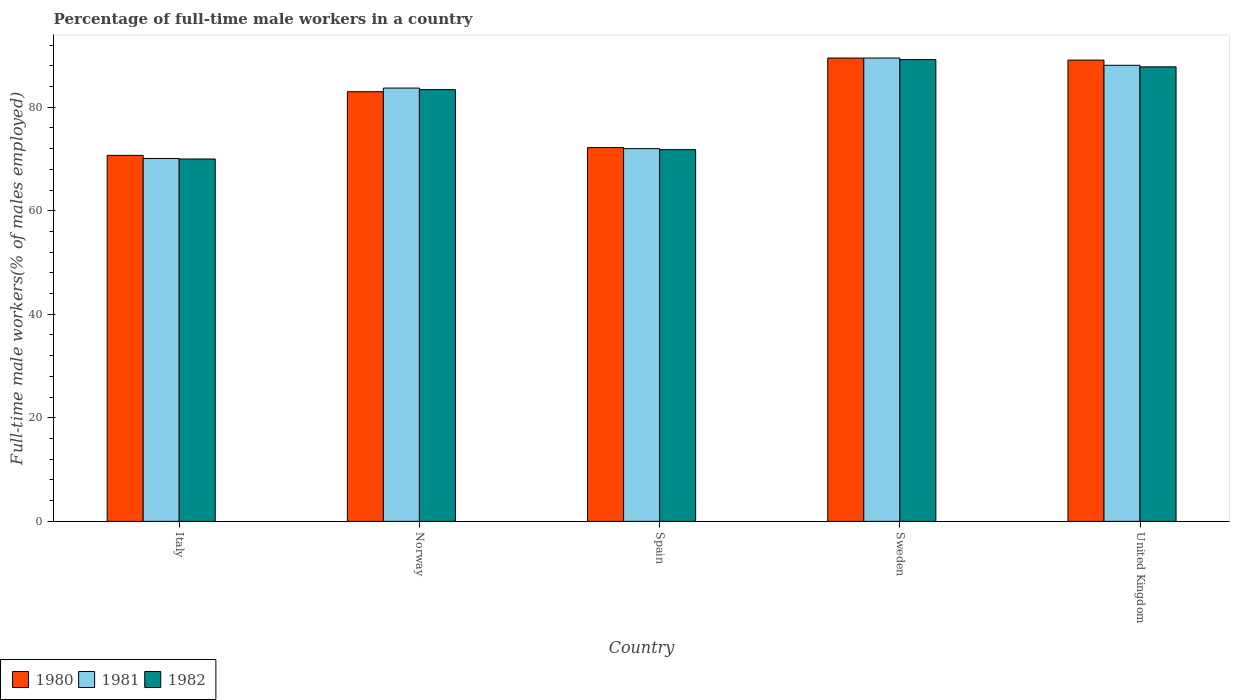How many different coloured bars are there?
Give a very brief answer. 3. How many groups of bars are there?
Provide a short and direct response. 5. Are the number of bars per tick equal to the number of legend labels?
Your answer should be compact. Yes. Are the number of bars on each tick of the X-axis equal?
Offer a terse response. Yes. How many bars are there on the 5th tick from the right?
Provide a succinct answer. 3. What is the label of the 1st group of bars from the left?
Give a very brief answer. Italy. In how many cases, is the number of bars for a given country not equal to the number of legend labels?
Your answer should be compact. 0. What is the percentage of full-time male workers in 1982 in United Kingdom?
Your response must be concise. 87.8. Across all countries, what is the maximum percentage of full-time male workers in 1982?
Offer a terse response. 89.2. Across all countries, what is the minimum percentage of full-time male workers in 1982?
Keep it short and to the point. 70. In which country was the percentage of full-time male workers in 1981 maximum?
Your response must be concise. Sweden. In which country was the percentage of full-time male workers in 1981 minimum?
Provide a succinct answer. Italy. What is the total percentage of full-time male workers in 1980 in the graph?
Offer a terse response. 404.5. What is the difference between the percentage of full-time male workers in 1981 in Spain and the percentage of full-time male workers in 1980 in Italy?
Your response must be concise. 1.3. What is the average percentage of full-time male workers in 1981 per country?
Provide a succinct answer. 80.68. What is the difference between the percentage of full-time male workers of/in 1982 and percentage of full-time male workers of/in 1981 in Sweden?
Keep it short and to the point. -0.3. In how many countries, is the percentage of full-time male workers in 1980 greater than 24 %?
Provide a succinct answer. 5. What is the ratio of the percentage of full-time male workers in 1982 in Norway to that in United Kingdom?
Make the answer very short. 0.95. What is the difference between the highest and the second highest percentage of full-time male workers in 1980?
Your answer should be very brief. -0.4. What is the difference between the highest and the lowest percentage of full-time male workers in 1982?
Offer a terse response. 19.2. Is the sum of the percentage of full-time male workers in 1980 in Italy and Norway greater than the maximum percentage of full-time male workers in 1982 across all countries?
Offer a very short reply. Yes. What does the 2nd bar from the left in Spain represents?
Provide a short and direct response. 1981. What does the 3rd bar from the right in Italy represents?
Offer a very short reply. 1980. How many bars are there?
Provide a short and direct response. 15. Are all the bars in the graph horizontal?
Provide a short and direct response. No. How many countries are there in the graph?
Make the answer very short. 5. Does the graph contain any zero values?
Give a very brief answer. No. Does the graph contain grids?
Your answer should be compact. No. How many legend labels are there?
Keep it short and to the point. 3. How are the legend labels stacked?
Keep it short and to the point. Horizontal. What is the title of the graph?
Offer a terse response. Percentage of full-time male workers in a country. What is the label or title of the Y-axis?
Your response must be concise. Full-time male workers(% of males employed). What is the Full-time male workers(% of males employed) of 1980 in Italy?
Your response must be concise. 70.7. What is the Full-time male workers(% of males employed) of 1981 in Italy?
Ensure brevity in your answer.  70.1. What is the Full-time male workers(% of males employed) of 1982 in Italy?
Keep it short and to the point. 70. What is the Full-time male workers(% of males employed) in 1980 in Norway?
Keep it short and to the point. 83. What is the Full-time male workers(% of males employed) of 1981 in Norway?
Provide a succinct answer. 83.7. What is the Full-time male workers(% of males employed) in 1982 in Norway?
Ensure brevity in your answer.  83.4. What is the Full-time male workers(% of males employed) of 1980 in Spain?
Make the answer very short. 72.2. What is the Full-time male workers(% of males employed) of 1981 in Spain?
Provide a short and direct response. 72. What is the Full-time male workers(% of males employed) in 1982 in Spain?
Provide a succinct answer. 71.8. What is the Full-time male workers(% of males employed) of 1980 in Sweden?
Offer a terse response. 89.5. What is the Full-time male workers(% of males employed) in 1981 in Sweden?
Offer a very short reply. 89.5. What is the Full-time male workers(% of males employed) in 1982 in Sweden?
Offer a terse response. 89.2. What is the Full-time male workers(% of males employed) of 1980 in United Kingdom?
Your answer should be compact. 89.1. What is the Full-time male workers(% of males employed) of 1981 in United Kingdom?
Offer a very short reply. 88.1. What is the Full-time male workers(% of males employed) in 1982 in United Kingdom?
Offer a very short reply. 87.8. Across all countries, what is the maximum Full-time male workers(% of males employed) of 1980?
Provide a short and direct response. 89.5. Across all countries, what is the maximum Full-time male workers(% of males employed) of 1981?
Keep it short and to the point. 89.5. Across all countries, what is the maximum Full-time male workers(% of males employed) in 1982?
Offer a terse response. 89.2. Across all countries, what is the minimum Full-time male workers(% of males employed) of 1980?
Your answer should be compact. 70.7. Across all countries, what is the minimum Full-time male workers(% of males employed) of 1981?
Provide a short and direct response. 70.1. Across all countries, what is the minimum Full-time male workers(% of males employed) in 1982?
Your answer should be compact. 70. What is the total Full-time male workers(% of males employed) of 1980 in the graph?
Your answer should be compact. 404.5. What is the total Full-time male workers(% of males employed) of 1981 in the graph?
Your answer should be compact. 403.4. What is the total Full-time male workers(% of males employed) in 1982 in the graph?
Provide a short and direct response. 402.2. What is the difference between the Full-time male workers(% of males employed) of 1980 in Italy and that in Norway?
Your answer should be compact. -12.3. What is the difference between the Full-time male workers(% of males employed) of 1981 in Italy and that in Norway?
Your answer should be compact. -13.6. What is the difference between the Full-time male workers(% of males employed) of 1980 in Italy and that in Spain?
Make the answer very short. -1.5. What is the difference between the Full-time male workers(% of males employed) in 1981 in Italy and that in Spain?
Provide a short and direct response. -1.9. What is the difference between the Full-time male workers(% of males employed) in 1980 in Italy and that in Sweden?
Your response must be concise. -18.8. What is the difference between the Full-time male workers(% of males employed) of 1981 in Italy and that in Sweden?
Provide a succinct answer. -19.4. What is the difference between the Full-time male workers(% of males employed) of 1982 in Italy and that in Sweden?
Offer a very short reply. -19.2. What is the difference between the Full-time male workers(% of males employed) of 1980 in Italy and that in United Kingdom?
Your response must be concise. -18.4. What is the difference between the Full-time male workers(% of males employed) in 1981 in Italy and that in United Kingdom?
Your answer should be very brief. -18. What is the difference between the Full-time male workers(% of males employed) of 1982 in Italy and that in United Kingdom?
Provide a succinct answer. -17.8. What is the difference between the Full-time male workers(% of males employed) in 1980 in Norway and that in Spain?
Make the answer very short. 10.8. What is the difference between the Full-time male workers(% of males employed) of 1982 in Norway and that in Spain?
Your response must be concise. 11.6. What is the difference between the Full-time male workers(% of males employed) in 1982 in Norway and that in Sweden?
Provide a short and direct response. -5.8. What is the difference between the Full-time male workers(% of males employed) in 1980 in Norway and that in United Kingdom?
Make the answer very short. -6.1. What is the difference between the Full-time male workers(% of males employed) in 1982 in Norway and that in United Kingdom?
Offer a terse response. -4.4. What is the difference between the Full-time male workers(% of males employed) in 1980 in Spain and that in Sweden?
Your answer should be compact. -17.3. What is the difference between the Full-time male workers(% of males employed) of 1981 in Spain and that in Sweden?
Give a very brief answer. -17.5. What is the difference between the Full-time male workers(% of males employed) of 1982 in Spain and that in Sweden?
Your answer should be very brief. -17.4. What is the difference between the Full-time male workers(% of males employed) of 1980 in Spain and that in United Kingdom?
Offer a very short reply. -16.9. What is the difference between the Full-time male workers(% of males employed) of 1981 in Spain and that in United Kingdom?
Your answer should be very brief. -16.1. What is the difference between the Full-time male workers(% of males employed) in 1982 in Spain and that in United Kingdom?
Make the answer very short. -16. What is the difference between the Full-time male workers(% of males employed) of 1980 in Sweden and that in United Kingdom?
Provide a short and direct response. 0.4. What is the difference between the Full-time male workers(% of males employed) of 1982 in Sweden and that in United Kingdom?
Your response must be concise. 1.4. What is the difference between the Full-time male workers(% of males employed) of 1980 in Italy and the Full-time male workers(% of males employed) of 1981 in Norway?
Your answer should be very brief. -13. What is the difference between the Full-time male workers(% of males employed) of 1980 in Italy and the Full-time male workers(% of males employed) of 1981 in Spain?
Give a very brief answer. -1.3. What is the difference between the Full-time male workers(% of males employed) of 1981 in Italy and the Full-time male workers(% of males employed) of 1982 in Spain?
Ensure brevity in your answer.  -1.7. What is the difference between the Full-time male workers(% of males employed) of 1980 in Italy and the Full-time male workers(% of males employed) of 1981 in Sweden?
Offer a very short reply. -18.8. What is the difference between the Full-time male workers(% of males employed) in 1980 in Italy and the Full-time male workers(% of males employed) in 1982 in Sweden?
Give a very brief answer. -18.5. What is the difference between the Full-time male workers(% of males employed) in 1981 in Italy and the Full-time male workers(% of males employed) in 1982 in Sweden?
Ensure brevity in your answer.  -19.1. What is the difference between the Full-time male workers(% of males employed) in 1980 in Italy and the Full-time male workers(% of males employed) in 1981 in United Kingdom?
Your response must be concise. -17.4. What is the difference between the Full-time male workers(% of males employed) in 1980 in Italy and the Full-time male workers(% of males employed) in 1982 in United Kingdom?
Keep it short and to the point. -17.1. What is the difference between the Full-time male workers(% of males employed) of 1981 in Italy and the Full-time male workers(% of males employed) of 1982 in United Kingdom?
Offer a very short reply. -17.7. What is the difference between the Full-time male workers(% of males employed) in 1980 in Norway and the Full-time male workers(% of males employed) in 1982 in Spain?
Offer a very short reply. 11.2. What is the difference between the Full-time male workers(% of males employed) in 1981 in Norway and the Full-time male workers(% of males employed) in 1982 in Spain?
Provide a short and direct response. 11.9. What is the difference between the Full-time male workers(% of males employed) of 1980 in Norway and the Full-time male workers(% of males employed) of 1981 in Sweden?
Your answer should be compact. -6.5. What is the difference between the Full-time male workers(% of males employed) in 1981 in Norway and the Full-time male workers(% of males employed) in 1982 in Sweden?
Make the answer very short. -5.5. What is the difference between the Full-time male workers(% of males employed) in 1980 in Norway and the Full-time male workers(% of males employed) in 1982 in United Kingdom?
Offer a terse response. -4.8. What is the difference between the Full-time male workers(% of males employed) of 1981 in Norway and the Full-time male workers(% of males employed) of 1982 in United Kingdom?
Your answer should be very brief. -4.1. What is the difference between the Full-time male workers(% of males employed) of 1980 in Spain and the Full-time male workers(% of males employed) of 1981 in Sweden?
Your answer should be very brief. -17.3. What is the difference between the Full-time male workers(% of males employed) of 1981 in Spain and the Full-time male workers(% of males employed) of 1982 in Sweden?
Offer a very short reply. -17.2. What is the difference between the Full-time male workers(% of males employed) in 1980 in Spain and the Full-time male workers(% of males employed) in 1981 in United Kingdom?
Keep it short and to the point. -15.9. What is the difference between the Full-time male workers(% of males employed) of 1980 in Spain and the Full-time male workers(% of males employed) of 1982 in United Kingdom?
Your answer should be very brief. -15.6. What is the difference between the Full-time male workers(% of males employed) of 1981 in Spain and the Full-time male workers(% of males employed) of 1982 in United Kingdom?
Keep it short and to the point. -15.8. What is the difference between the Full-time male workers(% of males employed) in 1980 in Sweden and the Full-time male workers(% of males employed) in 1981 in United Kingdom?
Give a very brief answer. 1.4. What is the difference between the Full-time male workers(% of males employed) in 1980 in Sweden and the Full-time male workers(% of males employed) in 1982 in United Kingdom?
Your answer should be compact. 1.7. What is the difference between the Full-time male workers(% of males employed) of 1981 in Sweden and the Full-time male workers(% of males employed) of 1982 in United Kingdom?
Your response must be concise. 1.7. What is the average Full-time male workers(% of males employed) of 1980 per country?
Make the answer very short. 80.9. What is the average Full-time male workers(% of males employed) in 1981 per country?
Your response must be concise. 80.68. What is the average Full-time male workers(% of males employed) of 1982 per country?
Your answer should be compact. 80.44. What is the difference between the Full-time male workers(% of males employed) in 1980 and Full-time male workers(% of males employed) in 1981 in Italy?
Offer a terse response. 0.6. What is the difference between the Full-time male workers(% of males employed) of 1980 and Full-time male workers(% of males employed) of 1982 in Norway?
Your response must be concise. -0.4. What is the difference between the Full-time male workers(% of males employed) in 1980 and Full-time male workers(% of males employed) in 1982 in Sweden?
Keep it short and to the point. 0.3. What is the difference between the Full-time male workers(% of males employed) in 1981 and Full-time male workers(% of males employed) in 1982 in Sweden?
Ensure brevity in your answer.  0.3. What is the ratio of the Full-time male workers(% of males employed) of 1980 in Italy to that in Norway?
Keep it short and to the point. 0.85. What is the ratio of the Full-time male workers(% of males employed) in 1981 in Italy to that in Norway?
Make the answer very short. 0.84. What is the ratio of the Full-time male workers(% of males employed) in 1982 in Italy to that in Norway?
Keep it short and to the point. 0.84. What is the ratio of the Full-time male workers(% of males employed) of 1980 in Italy to that in Spain?
Offer a very short reply. 0.98. What is the ratio of the Full-time male workers(% of males employed) of 1981 in Italy to that in Spain?
Your answer should be very brief. 0.97. What is the ratio of the Full-time male workers(% of males employed) in 1982 in Italy to that in Spain?
Keep it short and to the point. 0.97. What is the ratio of the Full-time male workers(% of males employed) in 1980 in Italy to that in Sweden?
Give a very brief answer. 0.79. What is the ratio of the Full-time male workers(% of males employed) in 1981 in Italy to that in Sweden?
Offer a very short reply. 0.78. What is the ratio of the Full-time male workers(% of males employed) of 1982 in Italy to that in Sweden?
Provide a succinct answer. 0.78. What is the ratio of the Full-time male workers(% of males employed) of 1980 in Italy to that in United Kingdom?
Your response must be concise. 0.79. What is the ratio of the Full-time male workers(% of males employed) in 1981 in Italy to that in United Kingdom?
Provide a succinct answer. 0.8. What is the ratio of the Full-time male workers(% of males employed) in 1982 in Italy to that in United Kingdom?
Your response must be concise. 0.8. What is the ratio of the Full-time male workers(% of males employed) of 1980 in Norway to that in Spain?
Provide a succinct answer. 1.15. What is the ratio of the Full-time male workers(% of males employed) of 1981 in Norway to that in Spain?
Provide a short and direct response. 1.16. What is the ratio of the Full-time male workers(% of males employed) in 1982 in Norway to that in Spain?
Keep it short and to the point. 1.16. What is the ratio of the Full-time male workers(% of males employed) in 1980 in Norway to that in Sweden?
Your answer should be very brief. 0.93. What is the ratio of the Full-time male workers(% of males employed) of 1981 in Norway to that in Sweden?
Your response must be concise. 0.94. What is the ratio of the Full-time male workers(% of males employed) in 1982 in Norway to that in Sweden?
Offer a very short reply. 0.94. What is the ratio of the Full-time male workers(% of males employed) of 1980 in Norway to that in United Kingdom?
Give a very brief answer. 0.93. What is the ratio of the Full-time male workers(% of males employed) of 1981 in Norway to that in United Kingdom?
Make the answer very short. 0.95. What is the ratio of the Full-time male workers(% of males employed) of 1982 in Norway to that in United Kingdom?
Provide a succinct answer. 0.95. What is the ratio of the Full-time male workers(% of males employed) of 1980 in Spain to that in Sweden?
Your answer should be compact. 0.81. What is the ratio of the Full-time male workers(% of males employed) in 1981 in Spain to that in Sweden?
Make the answer very short. 0.8. What is the ratio of the Full-time male workers(% of males employed) in 1982 in Spain to that in Sweden?
Make the answer very short. 0.8. What is the ratio of the Full-time male workers(% of males employed) of 1980 in Spain to that in United Kingdom?
Give a very brief answer. 0.81. What is the ratio of the Full-time male workers(% of males employed) in 1981 in Spain to that in United Kingdom?
Provide a succinct answer. 0.82. What is the ratio of the Full-time male workers(% of males employed) of 1982 in Spain to that in United Kingdom?
Provide a succinct answer. 0.82. What is the ratio of the Full-time male workers(% of males employed) of 1980 in Sweden to that in United Kingdom?
Your answer should be very brief. 1. What is the ratio of the Full-time male workers(% of males employed) in 1981 in Sweden to that in United Kingdom?
Ensure brevity in your answer.  1.02. What is the ratio of the Full-time male workers(% of males employed) in 1982 in Sweden to that in United Kingdom?
Make the answer very short. 1.02. What is the difference between the highest and the lowest Full-time male workers(% of males employed) of 1982?
Your answer should be compact. 19.2. 